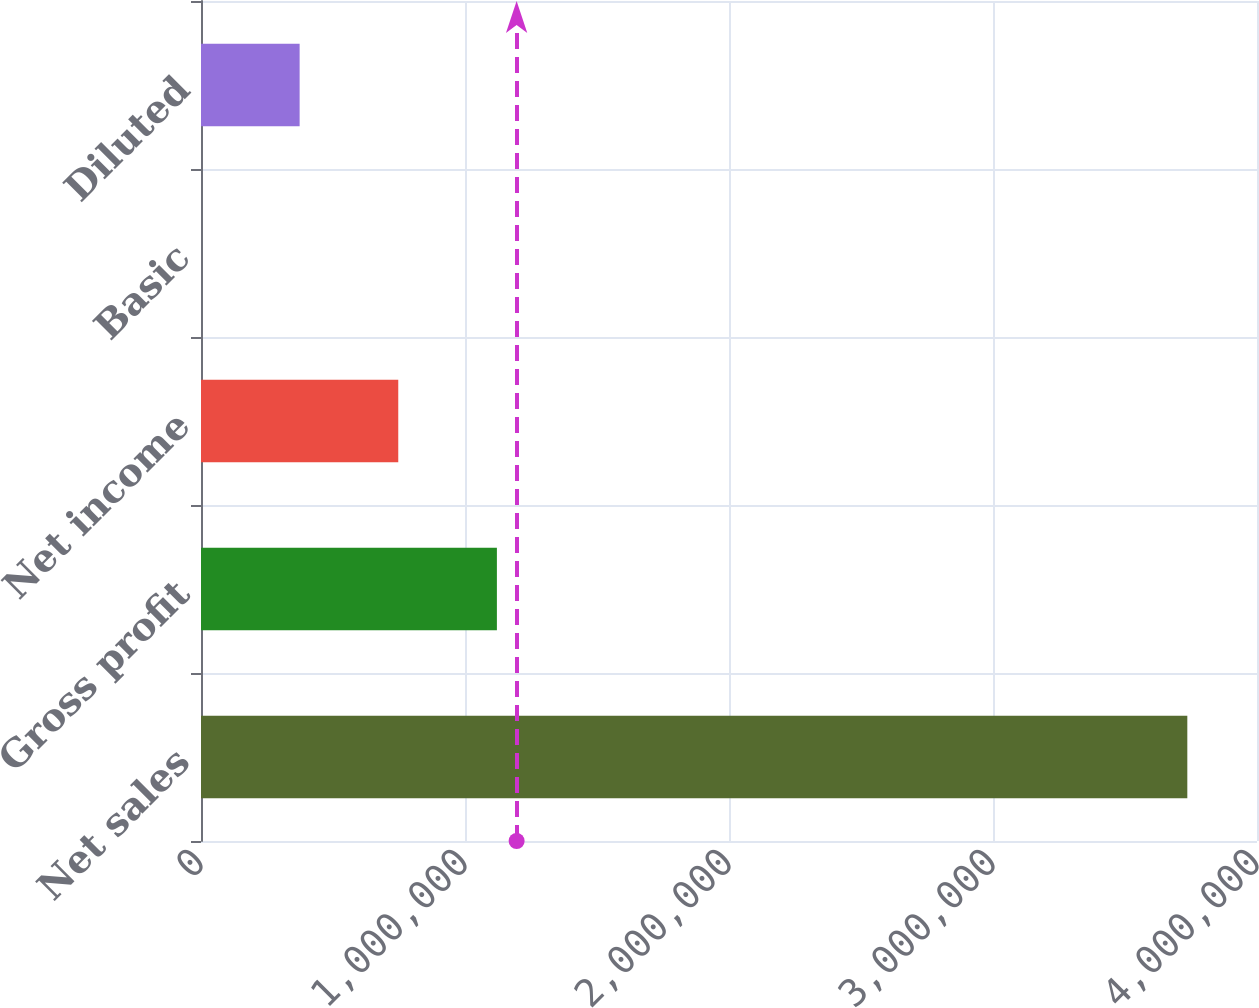Convert chart. <chart><loc_0><loc_0><loc_500><loc_500><bar_chart><fcel>Net sales<fcel>Gross profit<fcel>Net income<fcel>Basic<fcel>Diluted<nl><fcel>3.73605e+06<fcel>1.12082e+06<fcel>747211<fcel>1.05<fcel>373606<nl></chart> 